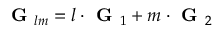Convert formula to latex. <formula><loc_0><loc_0><loc_500><loc_500>G _ { l m } = l \cdot G _ { 1 } + m \cdot G _ { 2 }</formula> 